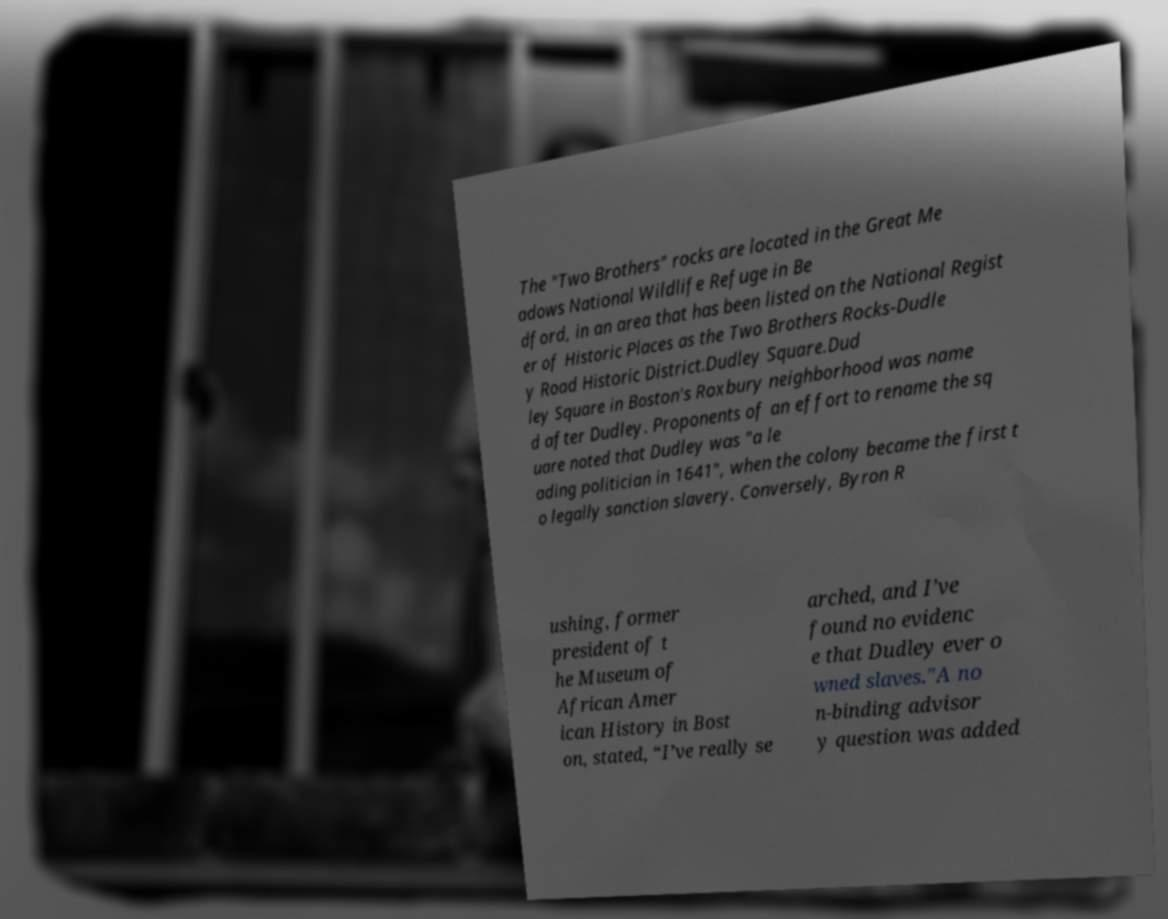Could you extract and type out the text from this image? The "Two Brothers" rocks are located in the Great Me adows National Wildlife Refuge in Be dford, in an area that has been listed on the National Regist er of Historic Places as the Two Brothers Rocks-Dudle y Road Historic District.Dudley Square.Dud ley Square in Boston's Roxbury neighborhood was name d after Dudley. Proponents of an effort to rename the sq uare noted that Dudley was "a le ading politician in 1641", when the colony became the first t o legally sanction slavery. Conversely, Byron R ushing, former president of t he Museum of African Amer ican History in Bost on, stated, “I’ve really se arched, and I’ve found no evidenc e that Dudley ever o wned slaves."A no n-binding advisor y question was added 